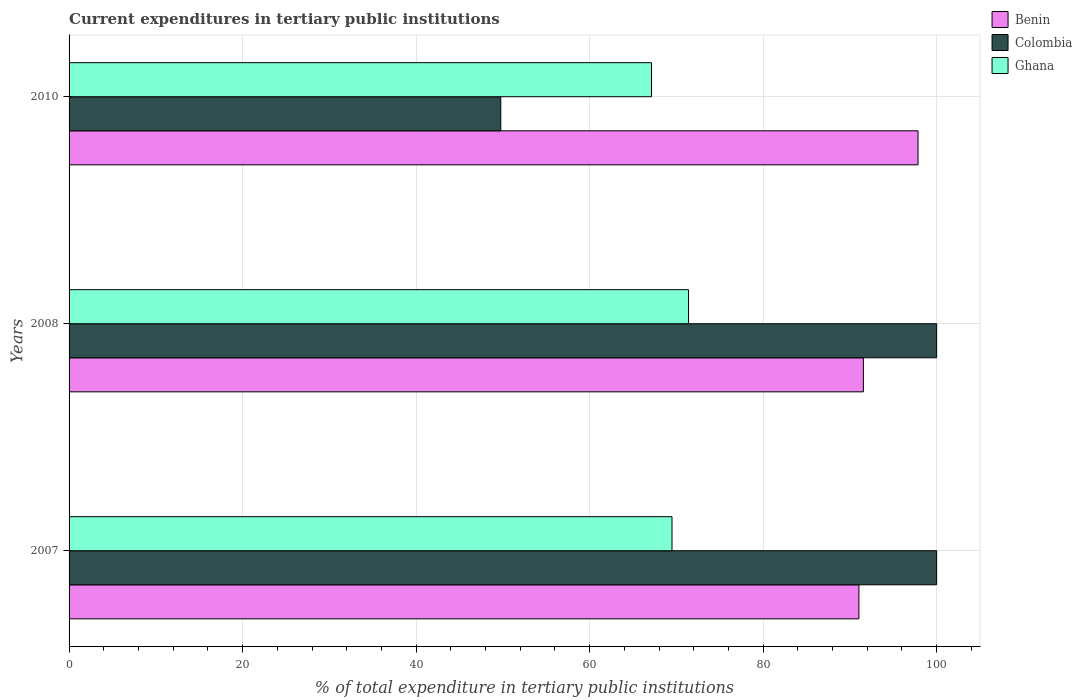How many different coloured bars are there?
Offer a terse response. 3. Are the number of bars per tick equal to the number of legend labels?
Keep it short and to the point. Yes. Are the number of bars on each tick of the Y-axis equal?
Give a very brief answer. Yes. How many bars are there on the 3rd tick from the top?
Provide a succinct answer. 3. What is the label of the 1st group of bars from the top?
Provide a succinct answer. 2010. In how many cases, is the number of bars for a given year not equal to the number of legend labels?
Your answer should be compact. 0. What is the current expenditures in tertiary public institutions in Ghana in 2007?
Your response must be concise. 69.49. Across all years, what is the maximum current expenditures in tertiary public institutions in Benin?
Ensure brevity in your answer.  97.85. Across all years, what is the minimum current expenditures in tertiary public institutions in Colombia?
Ensure brevity in your answer.  49.76. In which year was the current expenditures in tertiary public institutions in Benin minimum?
Make the answer very short. 2007. What is the total current expenditures in tertiary public institutions in Ghana in the graph?
Ensure brevity in your answer.  208.02. What is the difference between the current expenditures in tertiary public institutions in Colombia in 2007 and that in 2010?
Ensure brevity in your answer.  50.24. What is the difference between the current expenditures in tertiary public institutions in Benin in 2010 and the current expenditures in tertiary public institutions in Ghana in 2008?
Your response must be concise. 26.45. What is the average current expenditures in tertiary public institutions in Colombia per year?
Offer a terse response. 83.25. In the year 2008, what is the difference between the current expenditures in tertiary public institutions in Colombia and current expenditures in tertiary public institutions in Benin?
Provide a succinct answer. 8.44. In how many years, is the current expenditures in tertiary public institutions in Ghana greater than 12 %?
Your answer should be compact. 3. What is the ratio of the current expenditures in tertiary public institutions in Benin in 2008 to that in 2010?
Offer a very short reply. 0.94. Is the current expenditures in tertiary public institutions in Benin in 2007 less than that in 2008?
Your answer should be compact. Yes. Is the difference between the current expenditures in tertiary public institutions in Colombia in 2007 and 2008 greater than the difference between the current expenditures in tertiary public institutions in Benin in 2007 and 2008?
Offer a very short reply. Yes. What is the difference between the highest and the second highest current expenditures in tertiary public institutions in Benin?
Provide a short and direct response. 6.3. What is the difference between the highest and the lowest current expenditures in tertiary public institutions in Benin?
Give a very brief answer. 6.81. Is the sum of the current expenditures in tertiary public institutions in Benin in 2007 and 2010 greater than the maximum current expenditures in tertiary public institutions in Ghana across all years?
Your answer should be very brief. Yes. What does the 2nd bar from the top in 2010 represents?
Ensure brevity in your answer.  Colombia. Is it the case that in every year, the sum of the current expenditures in tertiary public institutions in Colombia and current expenditures in tertiary public institutions in Ghana is greater than the current expenditures in tertiary public institutions in Benin?
Your response must be concise. Yes. Are all the bars in the graph horizontal?
Offer a very short reply. Yes. What is the difference between two consecutive major ticks on the X-axis?
Your response must be concise. 20. Does the graph contain any zero values?
Offer a terse response. No. Does the graph contain grids?
Provide a succinct answer. Yes. How many legend labels are there?
Give a very brief answer. 3. How are the legend labels stacked?
Offer a very short reply. Vertical. What is the title of the graph?
Your answer should be very brief. Current expenditures in tertiary public institutions. Does "Canada" appear as one of the legend labels in the graph?
Your answer should be very brief. No. What is the label or title of the X-axis?
Your answer should be very brief. % of total expenditure in tertiary public institutions. What is the label or title of the Y-axis?
Your response must be concise. Years. What is the % of total expenditure in tertiary public institutions in Benin in 2007?
Make the answer very short. 91.04. What is the % of total expenditure in tertiary public institutions of Ghana in 2007?
Keep it short and to the point. 69.49. What is the % of total expenditure in tertiary public institutions in Benin in 2008?
Keep it short and to the point. 91.56. What is the % of total expenditure in tertiary public institutions of Ghana in 2008?
Your response must be concise. 71.4. What is the % of total expenditure in tertiary public institutions of Benin in 2010?
Offer a terse response. 97.85. What is the % of total expenditure in tertiary public institutions in Colombia in 2010?
Offer a very short reply. 49.76. What is the % of total expenditure in tertiary public institutions of Ghana in 2010?
Your answer should be compact. 67.13. Across all years, what is the maximum % of total expenditure in tertiary public institutions of Benin?
Give a very brief answer. 97.85. Across all years, what is the maximum % of total expenditure in tertiary public institutions of Ghana?
Provide a short and direct response. 71.4. Across all years, what is the minimum % of total expenditure in tertiary public institutions in Benin?
Provide a succinct answer. 91.04. Across all years, what is the minimum % of total expenditure in tertiary public institutions of Colombia?
Ensure brevity in your answer.  49.76. Across all years, what is the minimum % of total expenditure in tertiary public institutions of Ghana?
Your answer should be compact. 67.13. What is the total % of total expenditure in tertiary public institutions in Benin in the graph?
Keep it short and to the point. 280.45. What is the total % of total expenditure in tertiary public institutions of Colombia in the graph?
Your answer should be compact. 249.76. What is the total % of total expenditure in tertiary public institutions of Ghana in the graph?
Offer a very short reply. 208.02. What is the difference between the % of total expenditure in tertiary public institutions of Benin in 2007 and that in 2008?
Keep it short and to the point. -0.52. What is the difference between the % of total expenditure in tertiary public institutions of Ghana in 2007 and that in 2008?
Ensure brevity in your answer.  -1.91. What is the difference between the % of total expenditure in tertiary public institutions in Benin in 2007 and that in 2010?
Ensure brevity in your answer.  -6.81. What is the difference between the % of total expenditure in tertiary public institutions of Colombia in 2007 and that in 2010?
Your answer should be compact. 50.24. What is the difference between the % of total expenditure in tertiary public institutions of Ghana in 2007 and that in 2010?
Your answer should be very brief. 2.37. What is the difference between the % of total expenditure in tertiary public institutions in Benin in 2008 and that in 2010?
Your answer should be compact. -6.3. What is the difference between the % of total expenditure in tertiary public institutions in Colombia in 2008 and that in 2010?
Ensure brevity in your answer.  50.24. What is the difference between the % of total expenditure in tertiary public institutions of Ghana in 2008 and that in 2010?
Your response must be concise. 4.27. What is the difference between the % of total expenditure in tertiary public institutions in Benin in 2007 and the % of total expenditure in tertiary public institutions in Colombia in 2008?
Your answer should be compact. -8.96. What is the difference between the % of total expenditure in tertiary public institutions of Benin in 2007 and the % of total expenditure in tertiary public institutions of Ghana in 2008?
Provide a succinct answer. 19.64. What is the difference between the % of total expenditure in tertiary public institutions of Colombia in 2007 and the % of total expenditure in tertiary public institutions of Ghana in 2008?
Provide a short and direct response. 28.6. What is the difference between the % of total expenditure in tertiary public institutions of Benin in 2007 and the % of total expenditure in tertiary public institutions of Colombia in 2010?
Your response must be concise. 41.28. What is the difference between the % of total expenditure in tertiary public institutions in Benin in 2007 and the % of total expenditure in tertiary public institutions in Ghana in 2010?
Your answer should be compact. 23.91. What is the difference between the % of total expenditure in tertiary public institutions of Colombia in 2007 and the % of total expenditure in tertiary public institutions of Ghana in 2010?
Provide a short and direct response. 32.87. What is the difference between the % of total expenditure in tertiary public institutions in Benin in 2008 and the % of total expenditure in tertiary public institutions in Colombia in 2010?
Give a very brief answer. 41.8. What is the difference between the % of total expenditure in tertiary public institutions of Benin in 2008 and the % of total expenditure in tertiary public institutions of Ghana in 2010?
Provide a succinct answer. 24.43. What is the difference between the % of total expenditure in tertiary public institutions of Colombia in 2008 and the % of total expenditure in tertiary public institutions of Ghana in 2010?
Keep it short and to the point. 32.87. What is the average % of total expenditure in tertiary public institutions of Benin per year?
Your answer should be very brief. 93.48. What is the average % of total expenditure in tertiary public institutions in Colombia per year?
Keep it short and to the point. 83.25. What is the average % of total expenditure in tertiary public institutions in Ghana per year?
Your answer should be compact. 69.34. In the year 2007, what is the difference between the % of total expenditure in tertiary public institutions in Benin and % of total expenditure in tertiary public institutions in Colombia?
Make the answer very short. -8.96. In the year 2007, what is the difference between the % of total expenditure in tertiary public institutions in Benin and % of total expenditure in tertiary public institutions in Ghana?
Give a very brief answer. 21.54. In the year 2007, what is the difference between the % of total expenditure in tertiary public institutions of Colombia and % of total expenditure in tertiary public institutions of Ghana?
Keep it short and to the point. 30.51. In the year 2008, what is the difference between the % of total expenditure in tertiary public institutions of Benin and % of total expenditure in tertiary public institutions of Colombia?
Your answer should be very brief. -8.44. In the year 2008, what is the difference between the % of total expenditure in tertiary public institutions of Benin and % of total expenditure in tertiary public institutions of Ghana?
Offer a very short reply. 20.15. In the year 2008, what is the difference between the % of total expenditure in tertiary public institutions of Colombia and % of total expenditure in tertiary public institutions of Ghana?
Your answer should be compact. 28.6. In the year 2010, what is the difference between the % of total expenditure in tertiary public institutions of Benin and % of total expenditure in tertiary public institutions of Colombia?
Keep it short and to the point. 48.09. In the year 2010, what is the difference between the % of total expenditure in tertiary public institutions of Benin and % of total expenditure in tertiary public institutions of Ghana?
Provide a succinct answer. 30.72. In the year 2010, what is the difference between the % of total expenditure in tertiary public institutions in Colombia and % of total expenditure in tertiary public institutions in Ghana?
Your response must be concise. -17.37. What is the ratio of the % of total expenditure in tertiary public institutions in Ghana in 2007 to that in 2008?
Keep it short and to the point. 0.97. What is the ratio of the % of total expenditure in tertiary public institutions of Benin in 2007 to that in 2010?
Your answer should be very brief. 0.93. What is the ratio of the % of total expenditure in tertiary public institutions of Colombia in 2007 to that in 2010?
Keep it short and to the point. 2.01. What is the ratio of the % of total expenditure in tertiary public institutions in Ghana in 2007 to that in 2010?
Your answer should be compact. 1.04. What is the ratio of the % of total expenditure in tertiary public institutions in Benin in 2008 to that in 2010?
Keep it short and to the point. 0.94. What is the ratio of the % of total expenditure in tertiary public institutions of Colombia in 2008 to that in 2010?
Offer a very short reply. 2.01. What is the ratio of the % of total expenditure in tertiary public institutions in Ghana in 2008 to that in 2010?
Your response must be concise. 1.06. What is the difference between the highest and the second highest % of total expenditure in tertiary public institutions of Benin?
Your answer should be very brief. 6.3. What is the difference between the highest and the second highest % of total expenditure in tertiary public institutions in Ghana?
Keep it short and to the point. 1.91. What is the difference between the highest and the lowest % of total expenditure in tertiary public institutions in Benin?
Provide a short and direct response. 6.81. What is the difference between the highest and the lowest % of total expenditure in tertiary public institutions in Colombia?
Provide a succinct answer. 50.24. What is the difference between the highest and the lowest % of total expenditure in tertiary public institutions in Ghana?
Keep it short and to the point. 4.27. 